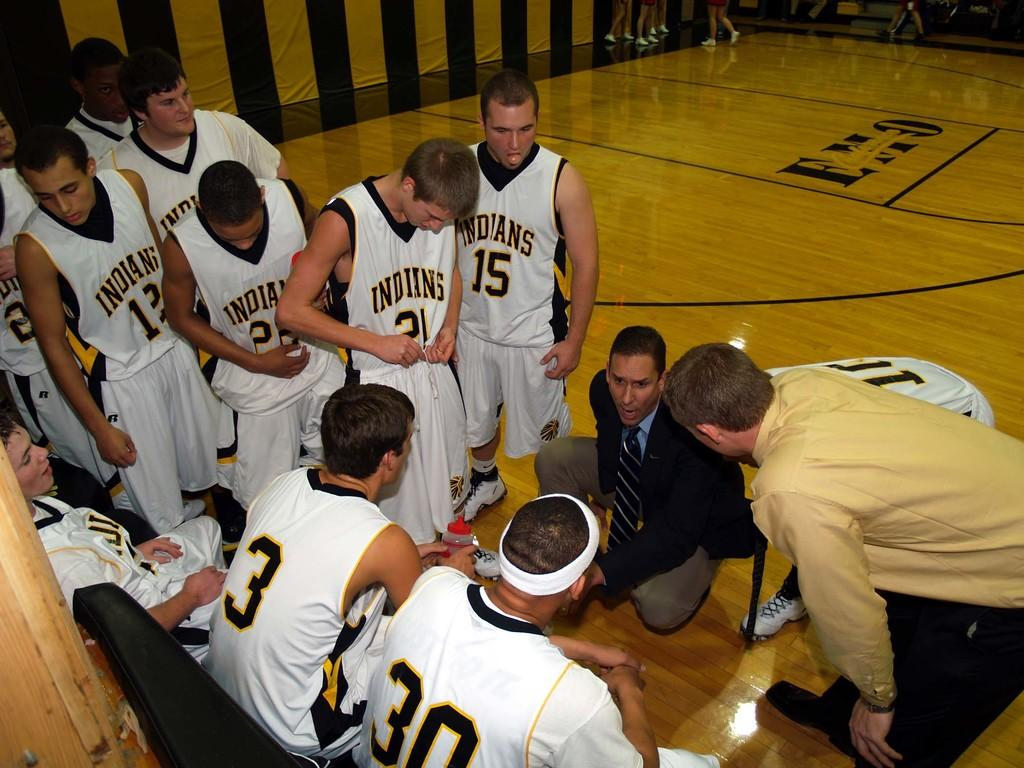<image>
Provide a brief description of the given image. a few players of basketball, one with the number 15 on it 